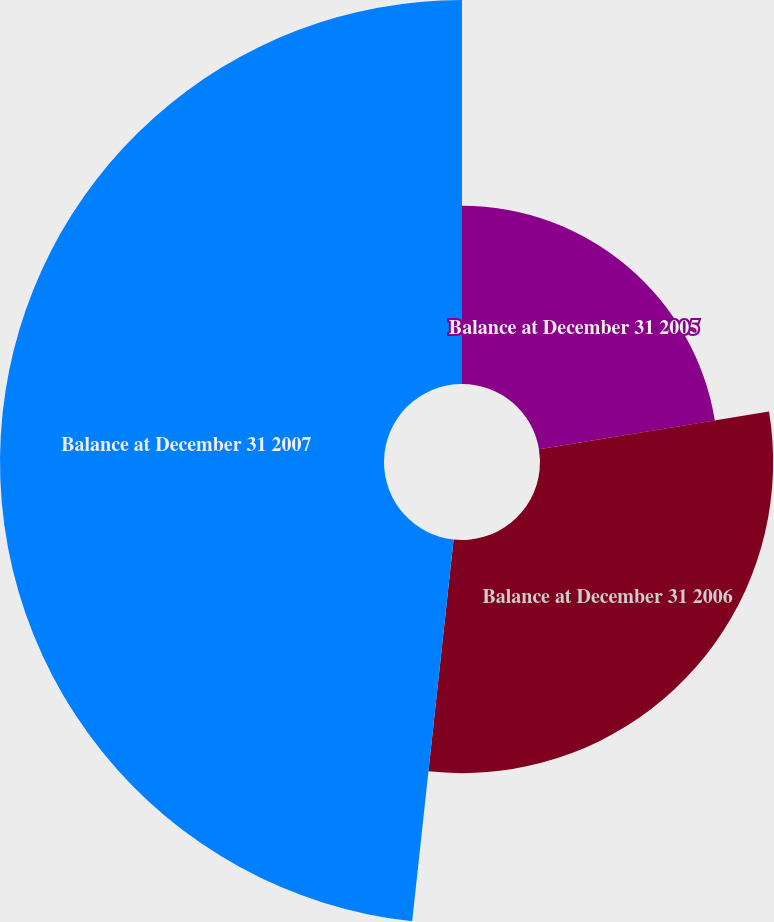Convert chart. <chart><loc_0><loc_0><loc_500><loc_500><pie_chart><fcel>Balance at December 31 2005<fcel>Balance at December 31 2006<fcel>Balance at December 31 2007<nl><fcel>22.41%<fcel>29.31%<fcel>48.28%<nl></chart> 